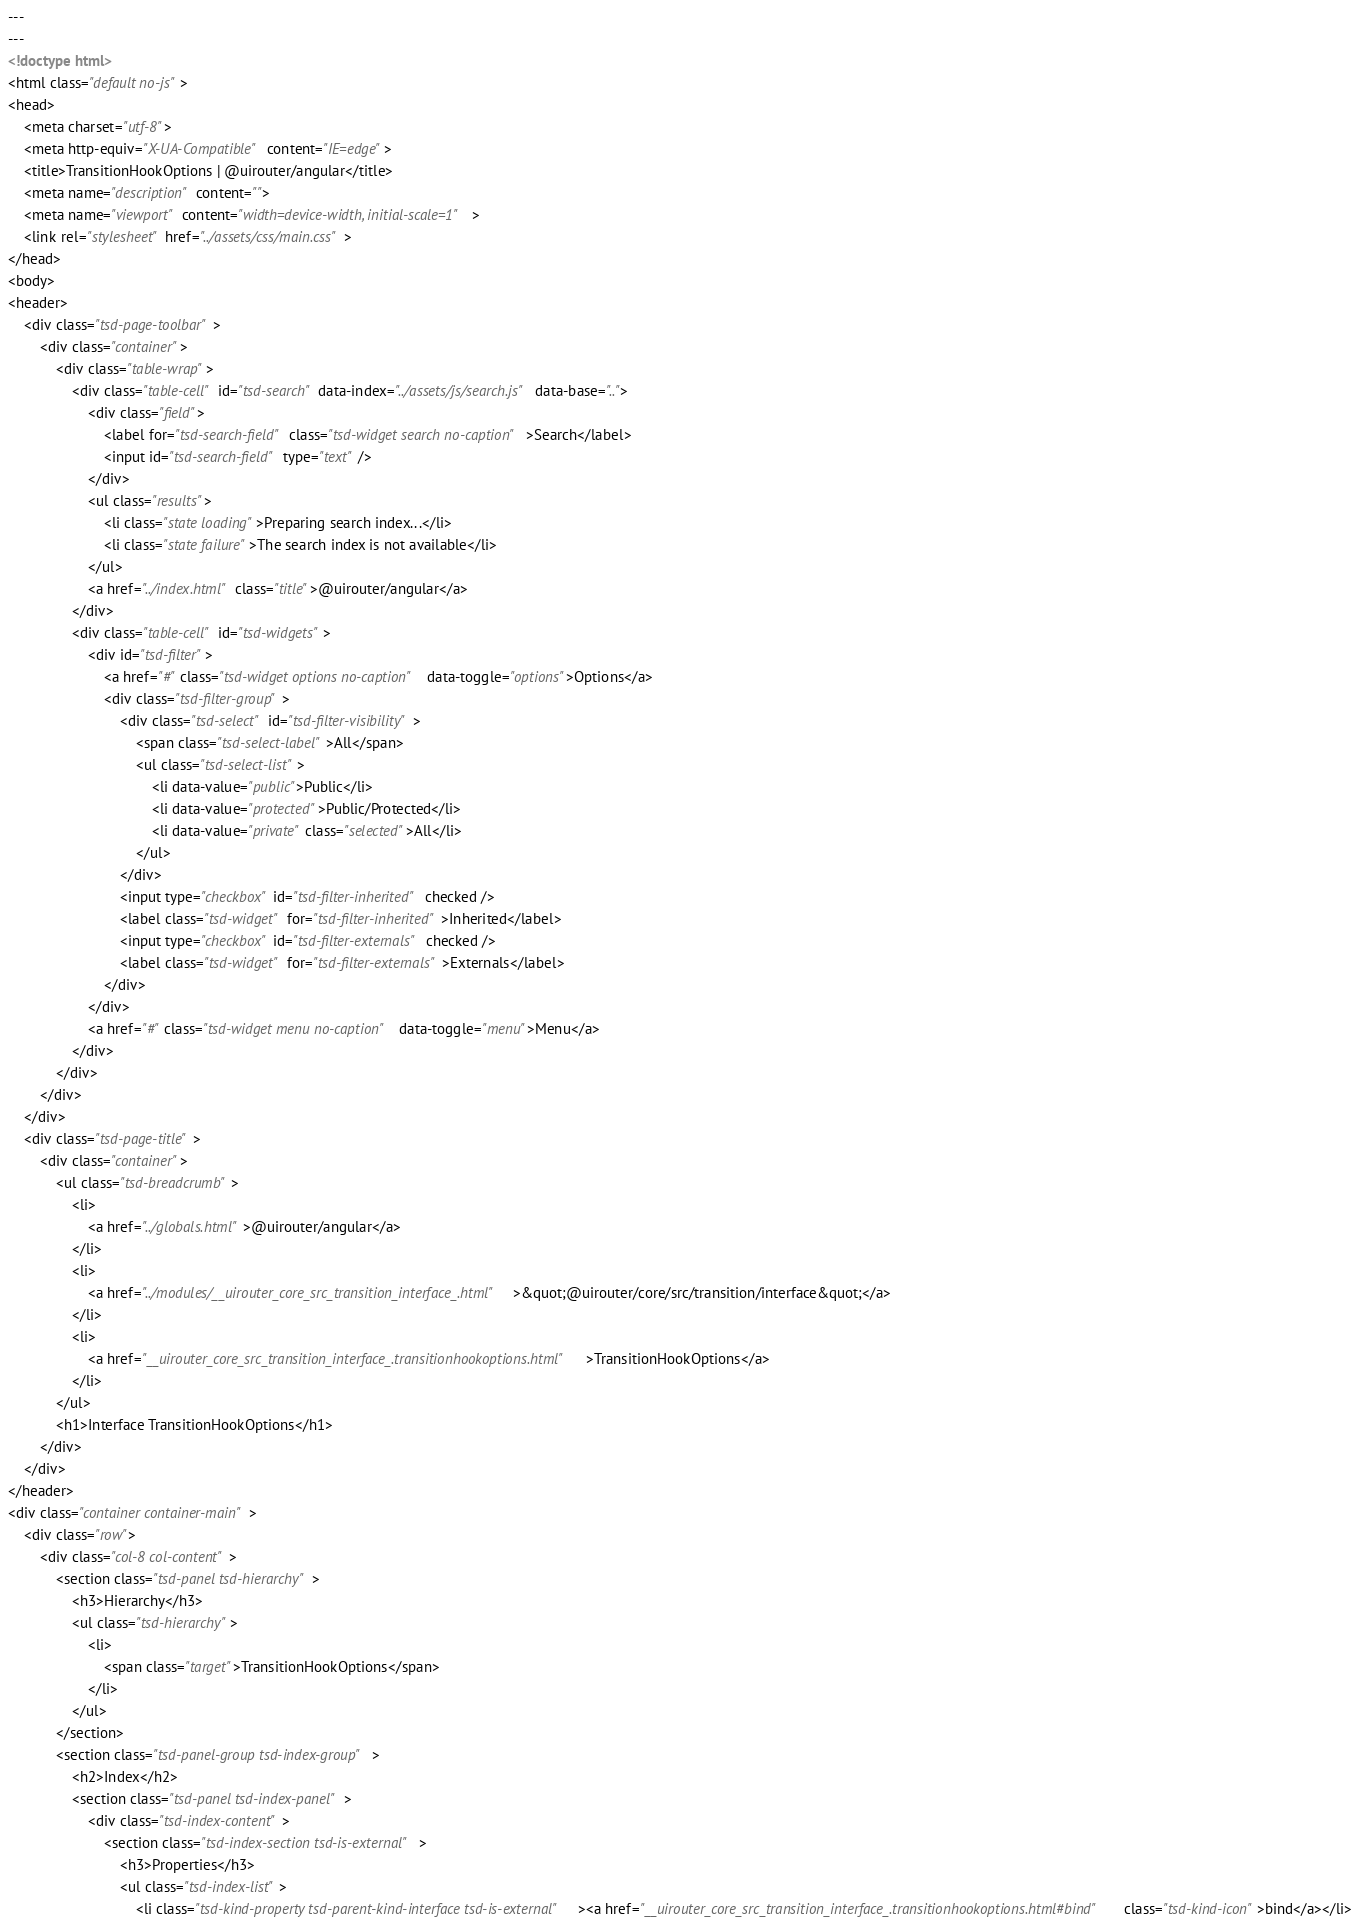<code> <loc_0><loc_0><loc_500><loc_500><_HTML_>---
---
<!doctype html>
<html class="default no-js">
<head>
	<meta charset="utf-8">
	<meta http-equiv="X-UA-Compatible" content="IE=edge">
	<title>TransitionHookOptions | @uirouter/angular</title>
	<meta name="description" content="">
	<meta name="viewport" content="width=device-width, initial-scale=1">
	<link rel="stylesheet" href="../assets/css/main.css">
</head>
<body>
<header>
	<div class="tsd-page-toolbar">
		<div class="container">
			<div class="table-wrap">
				<div class="table-cell" id="tsd-search" data-index="../assets/js/search.js" data-base="..">
					<div class="field">
						<label for="tsd-search-field" class="tsd-widget search no-caption">Search</label>
						<input id="tsd-search-field" type="text" />
					</div>
					<ul class="results">
						<li class="state loading">Preparing search index...</li>
						<li class="state failure">The search index is not available</li>
					</ul>
					<a href="../index.html" class="title">@uirouter/angular</a>
				</div>
				<div class="table-cell" id="tsd-widgets">
					<div id="tsd-filter">
						<a href="#" class="tsd-widget options no-caption" data-toggle="options">Options</a>
						<div class="tsd-filter-group">
							<div class="tsd-select" id="tsd-filter-visibility">
								<span class="tsd-select-label">All</span>
								<ul class="tsd-select-list">
									<li data-value="public">Public</li>
									<li data-value="protected">Public/Protected</li>
									<li data-value="private" class="selected">All</li>
								</ul>
							</div>
							<input type="checkbox" id="tsd-filter-inherited" checked />
							<label class="tsd-widget" for="tsd-filter-inherited">Inherited</label>
							<input type="checkbox" id="tsd-filter-externals" checked />
							<label class="tsd-widget" for="tsd-filter-externals">Externals</label>
						</div>
					</div>
					<a href="#" class="tsd-widget menu no-caption" data-toggle="menu">Menu</a>
				</div>
			</div>
		</div>
	</div>
	<div class="tsd-page-title">
		<div class="container">
			<ul class="tsd-breadcrumb">
				<li>
					<a href="../globals.html">@uirouter/angular</a>
				</li>
				<li>
					<a href="../modules/__uirouter_core_src_transition_interface_.html">&quot;@uirouter/core/src/transition/interface&quot;</a>
				</li>
				<li>
					<a href="__uirouter_core_src_transition_interface_.transitionhookoptions.html">TransitionHookOptions</a>
				</li>
			</ul>
			<h1>Interface TransitionHookOptions</h1>
		</div>
	</div>
</header>
<div class="container container-main">
	<div class="row">
		<div class="col-8 col-content">
			<section class="tsd-panel tsd-hierarchy">
				<h3>Hierarchy</h3>
				<ul class="tsd-hierarchy">
					<li>
						<span class="target">TransitionHookOptions</span>
					</li>
				</ul>
			</section>
			<section class="tsd-panel-group tsd-index-group">
				<h2>Index</h2>
				<section class="tsd-panel tsd-index-panel">
					<div class="tsd-index-content">
						<section class="tsd-index-section tsd-is-external">
							<h3>Properties</h3>
							<ul class="tsd-index-list">
								<li class="tsd-kind-property tsd-parent-kind-interface tsd-is-external"><a href="__uirouter_core_src_transition_interface_.transitionhookoptions.html#bind" class="tsd-kind-icon">bind</a></li></code> 